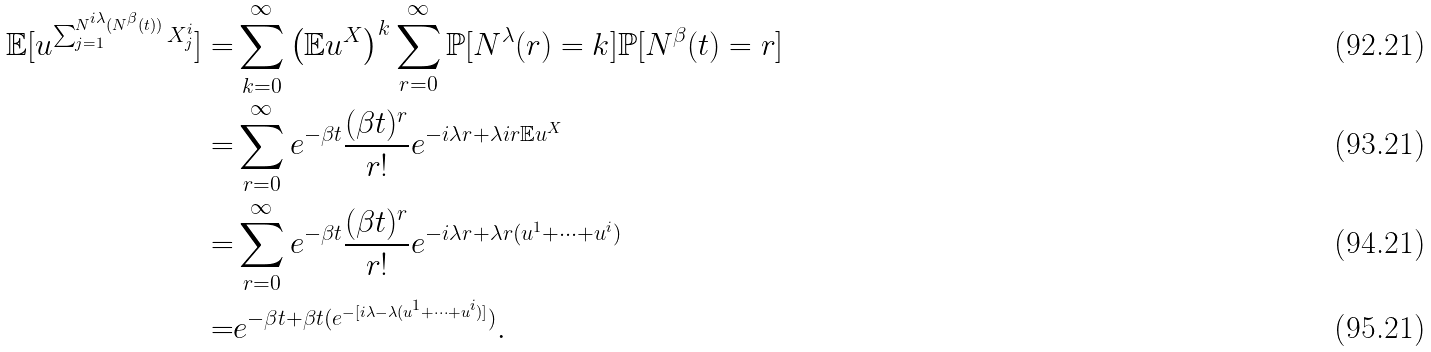Convert formula to latex. <formula><loc_0><loc_0><loc_500><loc_500>\mathbb { E } [ u ^ { \sum _ { j = 1 } ^ { N ^ { i \lambda } ( N ^ { \beta } ( t ) ) } X _ { j } ^ { i } } ] = & \sum _ { k = 0 } ^ { \infty } \left ( \mathbb { E } u ^ { X } \right ) ^ { k } \sum _ { r = 0 } ^ { \infty } \mathbb { P } [ N ^ { \lambda } ( r ) = k ] \mathbb { P } [ N ^ { \beta } ( t ) = r ] \\ = & \sum _ { r = 0 } ^ { \infty } e ^ { - \beta t } \frac { ( \beta t ) ^ { r } } { r ! } e ^ { - i \lambda r + \lambda i r \mathbb { E } u ^ { X } } \\ = & \sum _ { r = 0 } ^ { \infty } e ^ { - \beta t } \frac { ( \beta t ) ^ { r } } { r ! } e ^ { - i \lambda r + \lambda r ( u ^ { 1 } + \dots + u ^ { i } ) } \\ = & e ^ { - \beta t + \beta t ( e ^ { - [ i \lambda - \lambda ( u ^ { 1 } + \dots + u ^ { i } ) ] } ) } .</formula> 